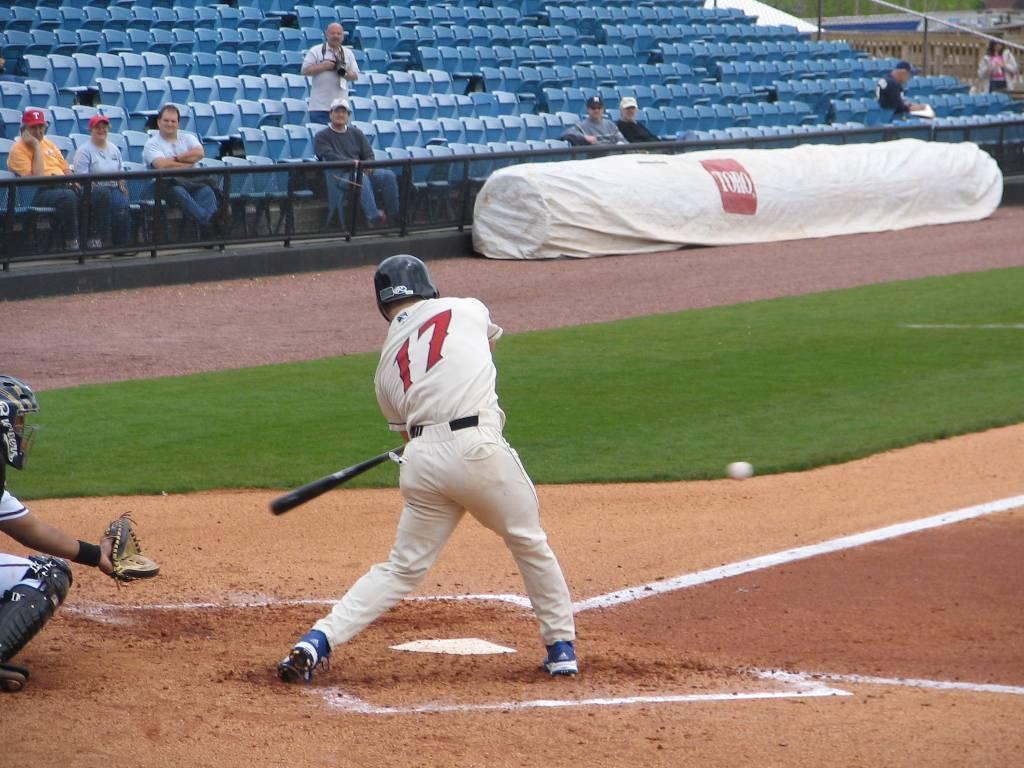What is the number of the batters jersey?
Ensure brevity in your answer.  17. 